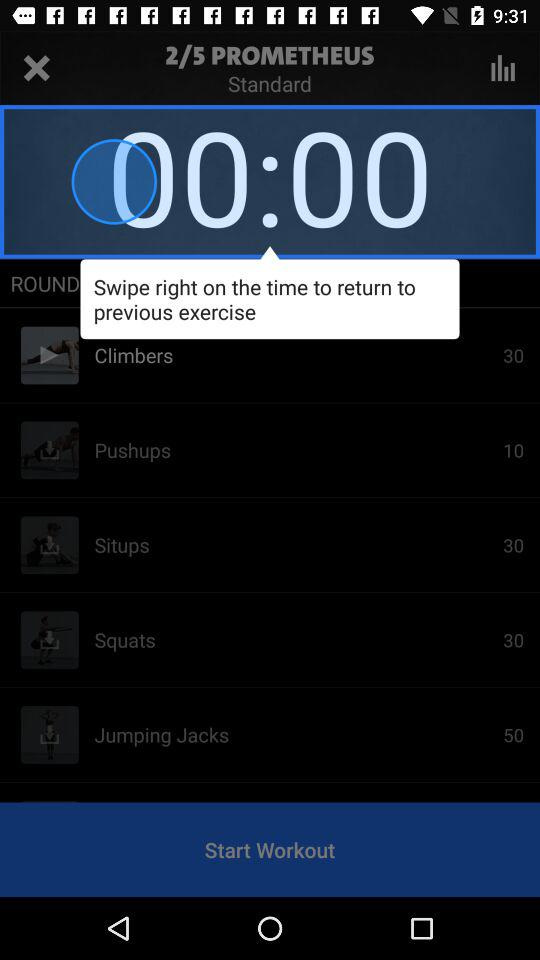How many exercises are in the workout?
Answer the question using a single word or phrase. 5 